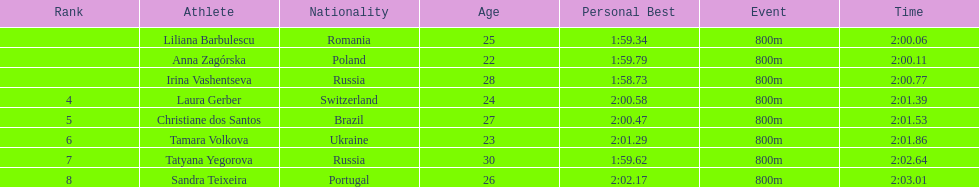Which country had the most finishers in the top 8? Russia. 